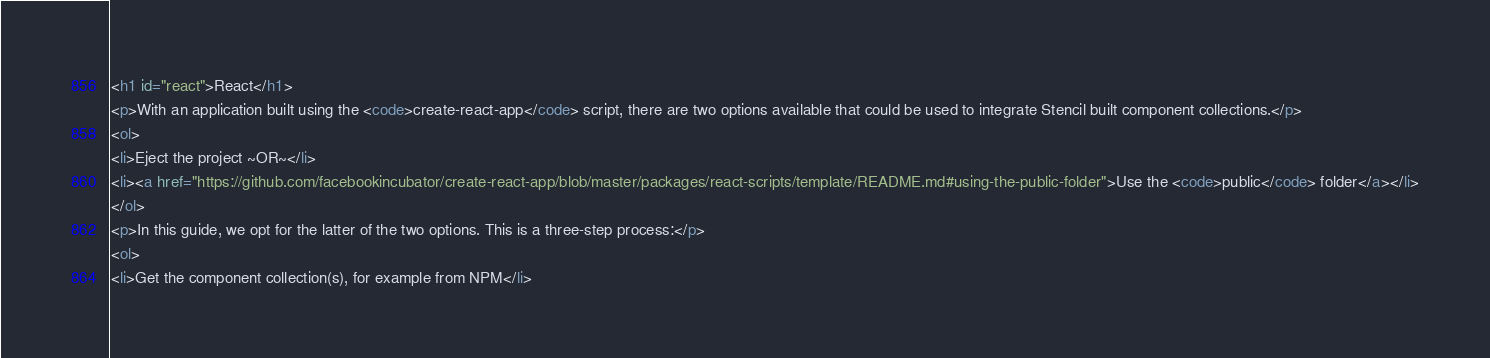Convert code to text. <code><loc_0><loc_0><loc_500><loc_500><_HTML_><h1 id="react">React</h1>
<p>With an application built using the <code>create-react-app</code> script, there are two options available that could be used to integrate Stencil built component collections.</p>
<ol>
<li>Eject the project ~OR~</li>
<li><a href="https://github.com/facebookincubator/create-react-app/blob/master/packages/react-scripts/template/README.md#using-the-public-folder">Use the <code>public</code> folder</a></li>
</ol>
<p>In this guide, we opt for the latter of the two options. This is a three-step process:</p>
<ol>
<li>Get the component collection(s), for example from NPM</li></code> 